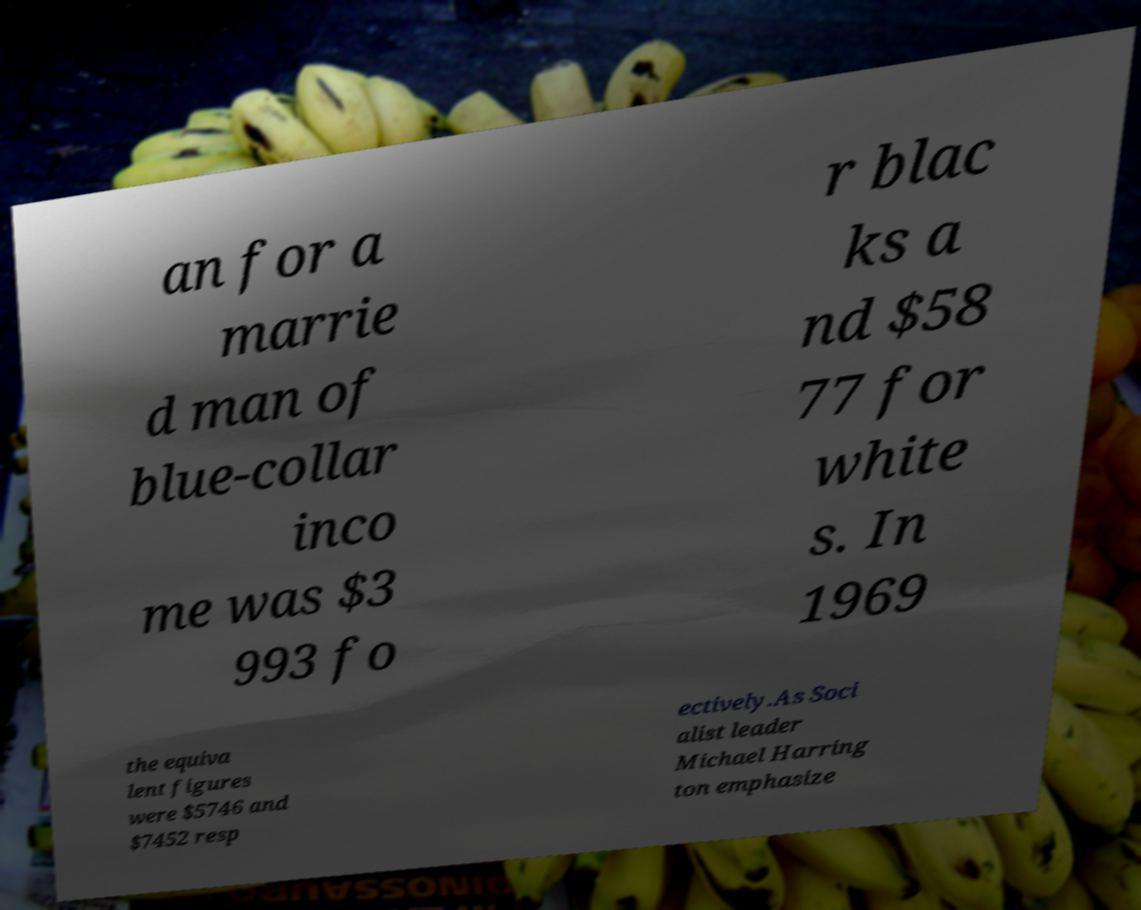Can you accurately transcribe the text from the provided image for me? an for a marrie d man of blue-collar inco me was $3 993 fo r blac ks a nd $58 77 for white s. In 1969 the equiva lent figures were $5746 and $7452 resp ectively.As Soci alist leader Michael Harring ton emphasize 